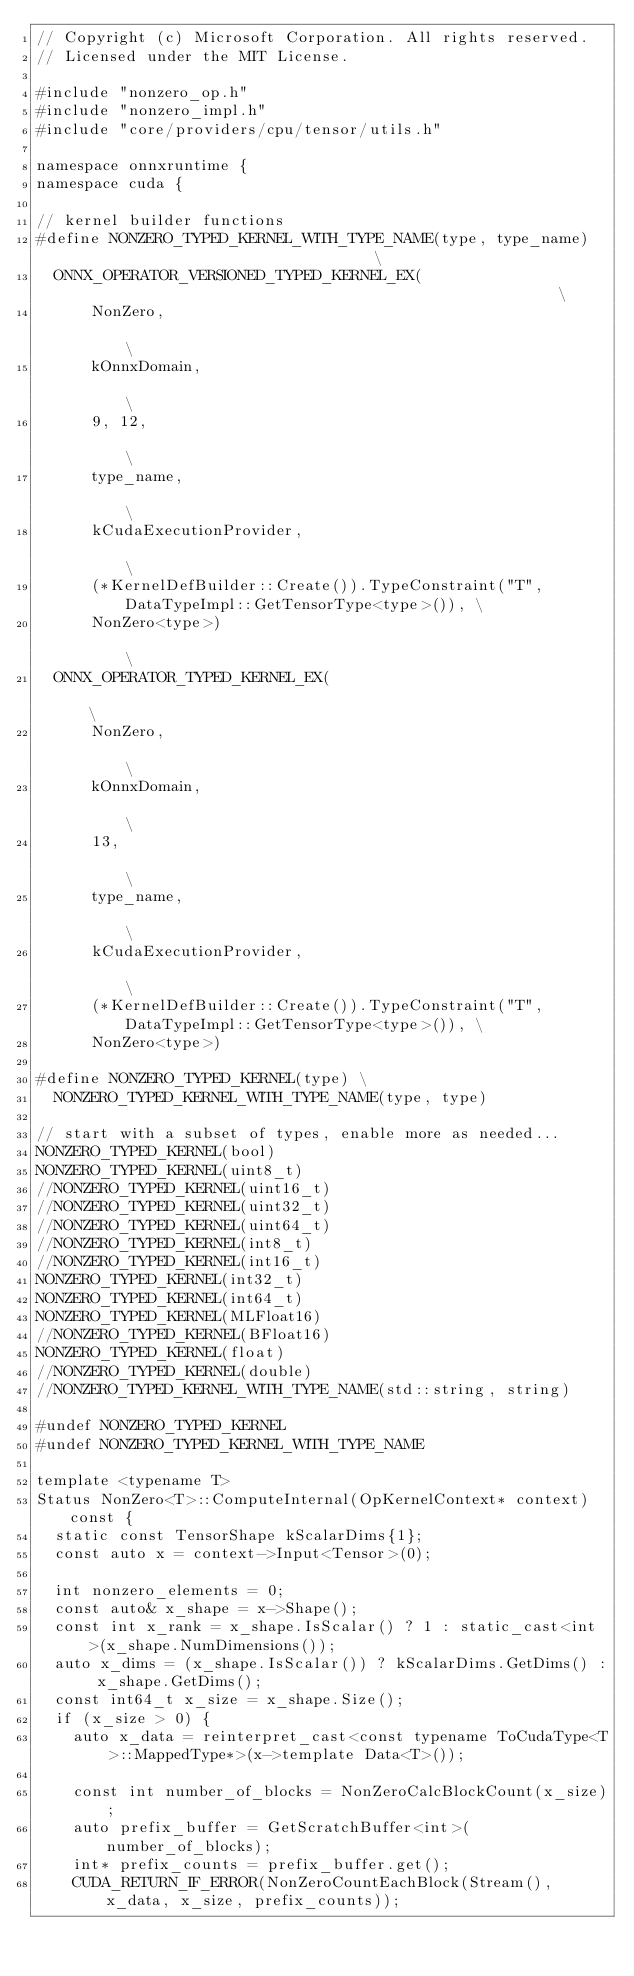<code> <loc_0><loc_0><loc_500><loc_500><_C++_>// Copyright (c) Microsoft Corporation. All rights reserved.
// Licensed under the MIT License.

#include "nonzero_op.h"
#include "nonzero_impl.h"
#include "core/providers/cpu/tensor/utils.h"

namespace onnxruntime {
namespace cuda {

// kernel builder functions
#define NONZERO_TYPED_KERNEL_WITH_TYPE_NAME(type, type_name)                                  \
  ONNX_OPERATOR_VERSIONED_TYPED_KERNEL_EX(                                                    \
      NonZero,                                                                                \
      kOnnxDomain,                                                                            \
      9, 12,                                                                                  \
      type_name,                                                                              \
      kCudaExecutionProvider,                                                                 \
      (*KernelDefBuilder::Create()).TypeConstraint("T", DataTypeImpl::GetTensorType<type>()), \
      NonZero<type>)                                                                          \
  ONNX_OPERATOR_TYPED_KERNEL_EX(                                                              \
      NonZero,                                                                                \
      kOnnxDomain,                                                                            \
      13,                                                                                     \
      type_name,                                                                              \
      kCudaExecutionProvider,                                                                 \
      (*KernelDefBuilder::Create()).TypeConstraint("T", DataTypeImpl::GetTensorType<type>()), \
      NonZero<type>)

#define NONZERO_TYPED_KERNEL(type) \
  NONZERO_TYPED_KERNEL_WITH_TYPE_NAME(type, type)

// start with a subset of types, enable more as needed...
NONZERO_TYPED_KERNEL(bool)
NONZERO_TYPED_KERNEL(uint8_t)
//NONZERO_TYPED_KERNEL(uint16_t)
//NONZERO_TYPED_KERNEL(uint32_t)
//NONZERO_TYPED_KERNEL(uint64_t)
//NONZERO_TYPED_KERNEL(int8_t)
//NONZERO_TYPED_KERNEL(int16_t)
NONZERO_TYPED_KERNEL(int32_t)
NONZERO_TYPED_KERNEL(int64_t)
NONZERO_TYPED_KERNEL(MLFloat16)
//NONZERO_TYPED_KERNEL(BFloat16)
NONZERO_TYPED_KERNEL(float)
//NONZERO_TYPED_KERNEL(double)
//NONZERO_TYPED_KERNEL_WITH_TYPE_NAME(std::string, string)

#undef NONZERO_TYPED_KERNEL
#undef NONZERO_TYPED_KERNEL_WITH_TYPE_NAME

template <typename T>
Status NonZero<T>::ComputeInternal(OpKernelContext* context) const {
  static const TensorShape kScalarDims{1};
  const auto x = context->Input<Tensor>(0);

  int nonzero_elements = 0;
  const auto& x_shape = x->Shape();
  const int x_rank = x_shape.IsScalar() ? 1 : static_cast<int>(x_shape.NumDimensions());
  auto x_dims = (x_shape.IsScalar()) ? kScalarDims.GetDims() : x_shape.GetDims();
  const int64_t x_size = x_shape.Size();
  if (x_size > 0) {
    auto x_data = reinterpret_cast<const typename ToCudaType<T>::MappedType*>(x->template Data<T>());

    const int number_of_blocks = NonZeroCalcBlockCount(x_size);
    auto prefix_buffer = GetScratchBuffer<int>(number_of_blocks);
    int* prefix_counts = prefix_buffer.get();
    CUDA_RETURN_IF_ERROR(NonZeroCountEachBlock(Stream(), x_data, x_size, prefix_counts));
</code> 